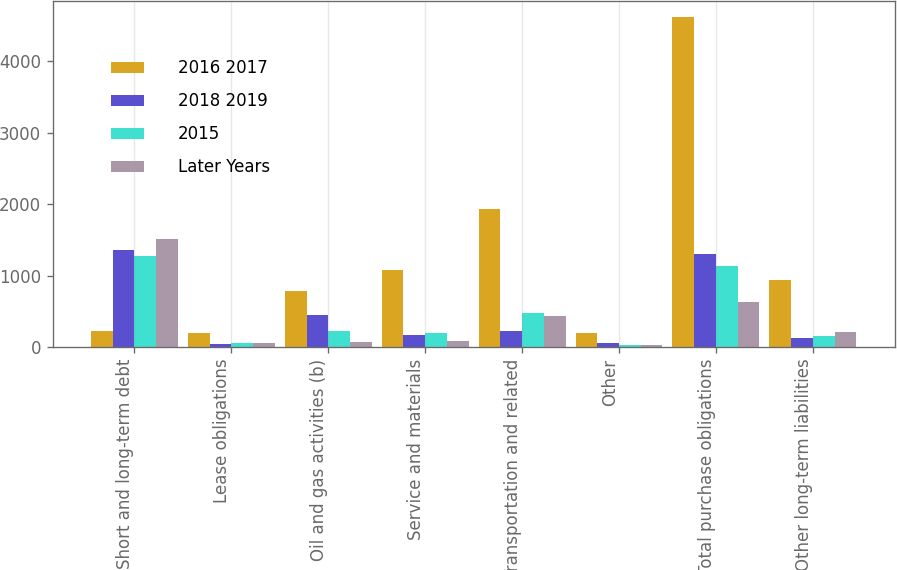<chart> <loc_0><loc_0><loc_500><loc_500><stacked_bar_chart><ecel><fcel>Short and long-term debt<fcel>Lease obligations<fcel>Oil and gas activities (b)<fcel>Service and materials<fcel>Transportation and related<fcel>Other<fcel>Total purchase obligations<fcel>Other long-term liabilities<nl><fcel>2016 2017<fcel>218<fcel>200<fcel>783<fcel>1077<fcel>1933<fcel>192<fcel>4614<fcel>943<nl><fcel>2018 2019<fcel>1363<fcel>41<fcel>442<fcel>166<fcel>222<fcel>50<fcel>1302<fcel>133<nl><fcel>2015<fcel>1272<fcel>61<fcel>218<fcel>199<fcel>475<fcel>29<fcel>1128<fcel>156<nl><fcel>Later Years<fcel>1508<fcel>50<fcel>74<fcel>89<fcel>434<fcel>30<fcel>627<fcel>214<nl></chart> 